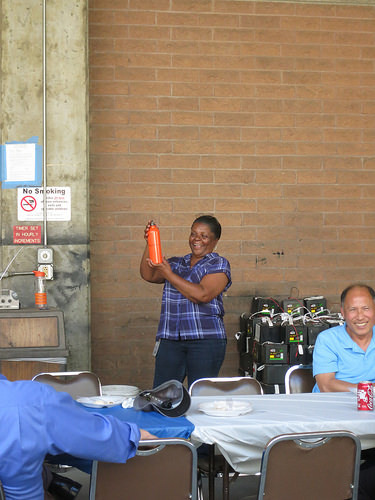<image>
Is there a woman to the left of the coke? Yes. From this viewpoint, the woman is positioned to the left side relative to the coke. Is the junk in front of the woman? No. The junk is not in front of the woman. The spatial positioning shows a different relationship between these objects. 